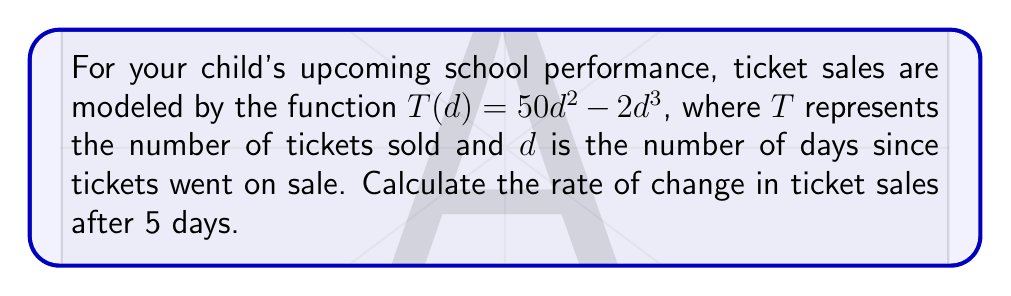Help me with this question. To find the rate of change in ticket sales after 5 days, we need to calculate the derivative of the given function $T(d)$ and then evaluate it at $d=5$.

Step 1: Find the derivative of $T(d)$.
$$\frac{dT}{dd} = \frac{d}{dd}(50d^2 - 2d^3)$$
Using the power rule:
$$\frac{dT}{dd} = 100d - 6d^2$$

Step 2: Evaluate the derivative at $d=5$.
$$\frac{dT}{dd}\bigg|_{d=5} = 100(5) - 6(5^2)$$
$$= 500 - 6(25)$$
$$= 500 - 150$$
$$= 350$$

Therefore, the rate of change in ticket sales after 5 days is 350 tickets per day.
Answer: $350$ tickets/day 